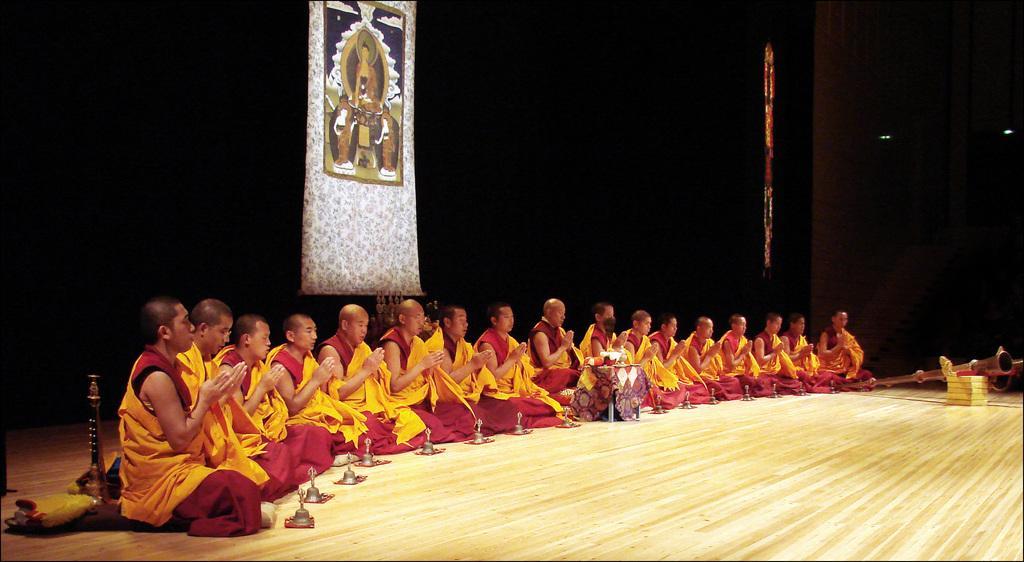Describe this image in one or two sentences. In this image we can see a few people sitting and doing prayer, in front of them, we can see some bells and clothes, also we can see a stool with some objects on it, in the background we can see the wall with a poster on it. 